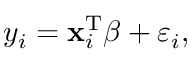Convert formula to latex. <formula><loc_0><loc_0><loc_500><loc_500>y _ { i } = x _ { i } ^ { T } { \beta } + \varepsilon _ { i } ,</formula> 